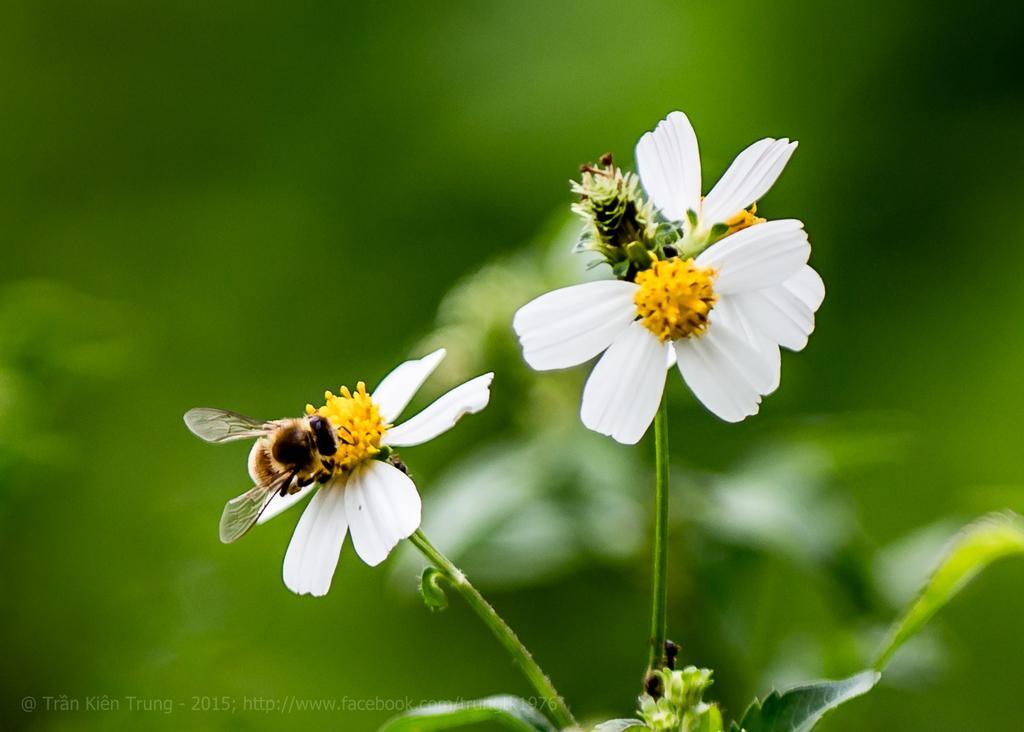Describe this image in one or two sentences. In this image we can see flowers, honey bees, leaves and stem. The background of the image is blur and green. On the image there is a watermark. 